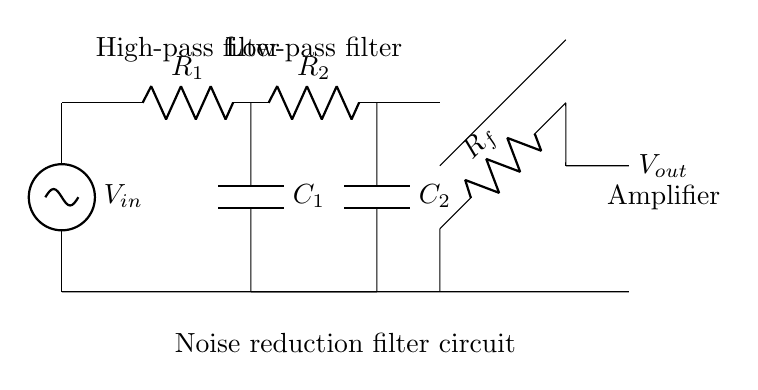What is the input voltage of the circuit? The input voltage is labeled as V_in at the left side of the circuit. It is the voltage that enters the circuit for processing.
Answer: V_in What is the role of the operational amplifier in this circuit? The operational amplifier is used to amplify the output signal after filtering, indicated by its label "Amplifier" in the diagram. This shows its purpose in enhancing the signal.
Answer: Amplifier Which components make up the high-pass filter? The high-pass filter consists of a resistor R_1 and a capacitor C_1, connected in series from the input signal to the operational amplifier. This setup allows high frequencies to pass while attenuating low frequencies.
Answer: R_1 and C_1 How many resistors are present in the circuit? There are three resistors present in the circuit: R_1, R_2, and R_f. These resistors are crucial for determining the frequency response and gain of the circuit.
Answer: Three What type of filter is R_2 and C_2 forming? R_2 and C_2 together create a low-pass filter, as indicated by their connection and function in the circuit to allow lower frequencies to pass while blocking higher frequencies.
Answer: Low-pass filter What is the function of the capacitor C_1? The capacitor C_1 acts as part of the high-pass filter, allowing high-frequency signals to pass and blocking low-frequency signals, enabling the noise reduction aspect of the circuit.
Answer: High-pass filtering 